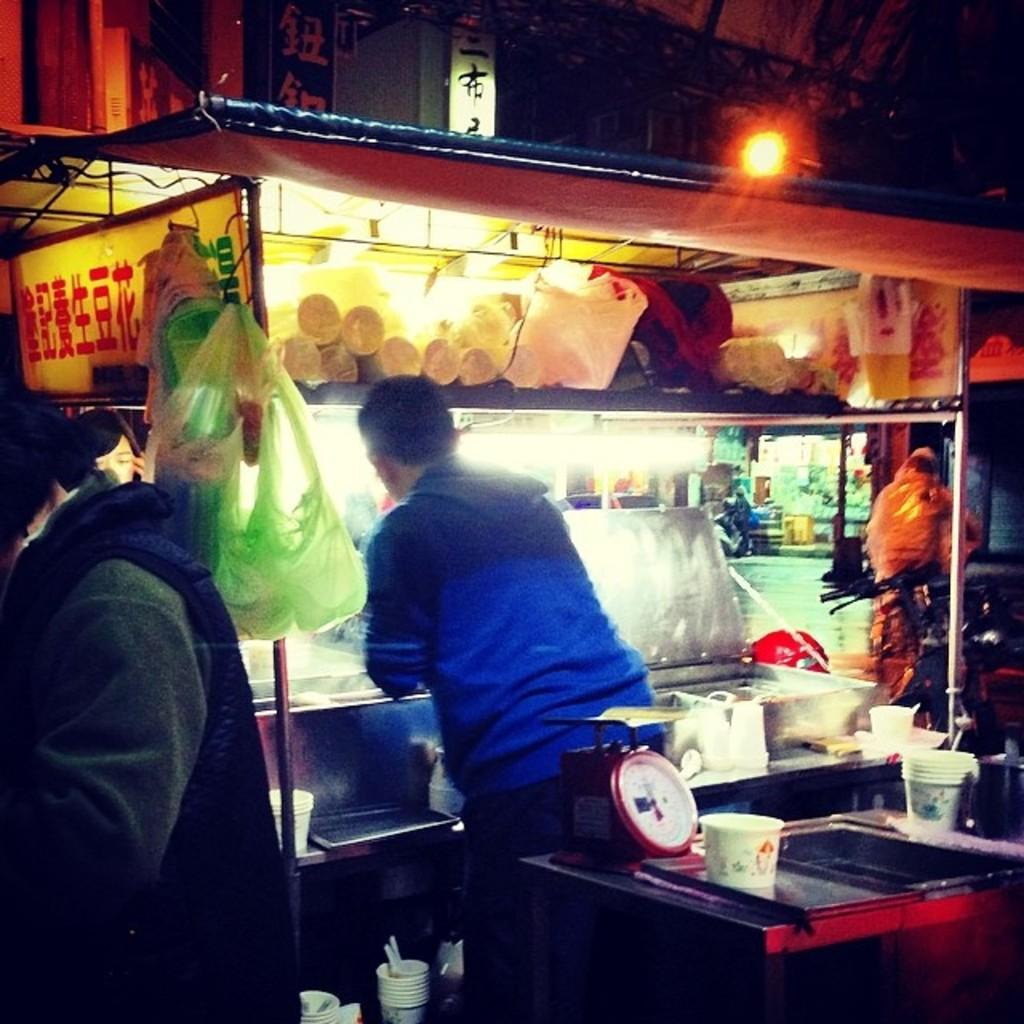What type of structures can be seen in the image? There are stalls in the image. What materials are used for the stalls? The image shows boards being used for the stalls. What can be seen in the image that provides illumination? Light is visible in the image. What might be used for carrying items in the image? Plastic bags are present in the image. Can you describe the people in the image? Yes, there are people in the image. What device is present in the image? There is a weighing machine in the image. What type of furniture is present in the image? There is a table in the image. What type of containers are present in the image? There are cups in the image. What other objects can be seen in the image? There are various objects in the image. Can you tell me the price of the stream in the image? There is no stream present in the image. 